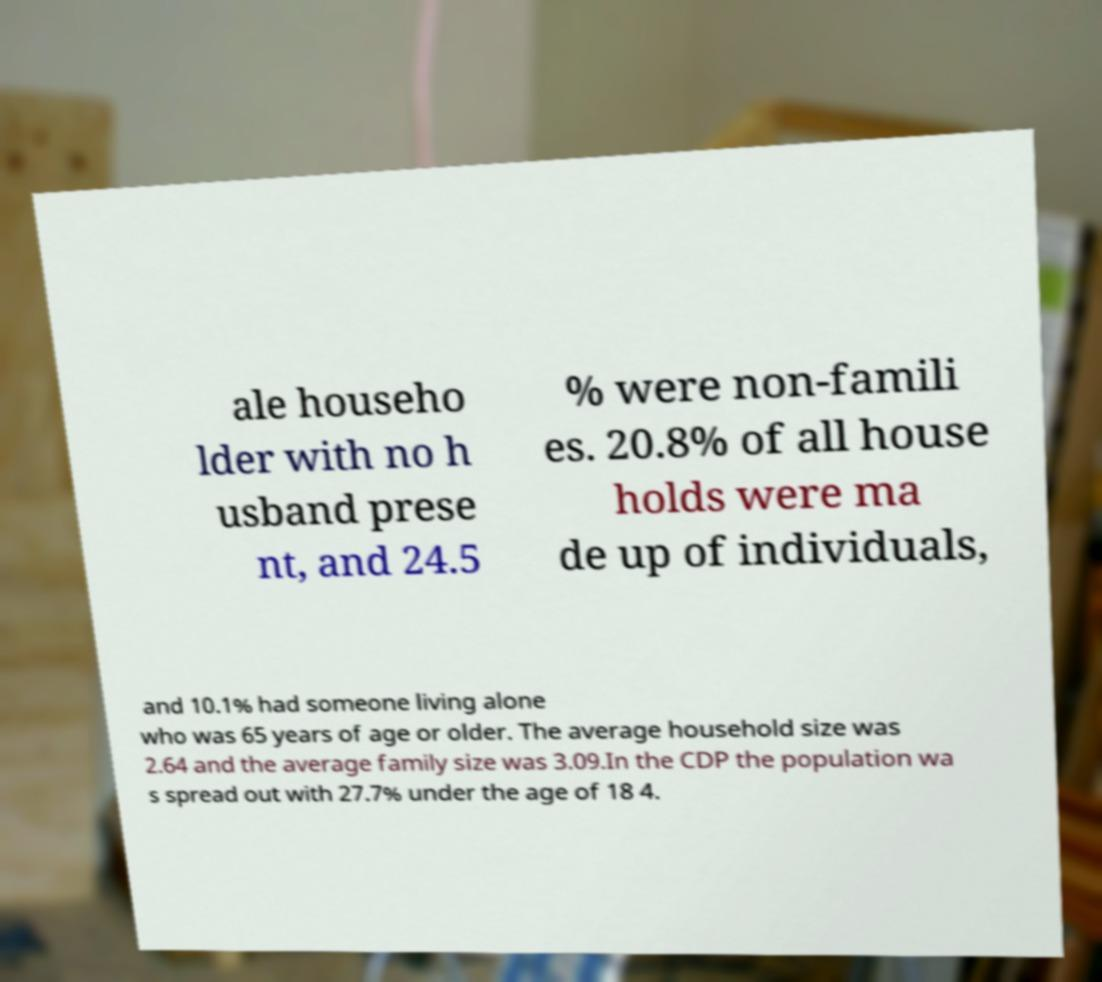Please read and relay the text visible in this image. What does it say? ale househo lder with no h usband prese nt, and 24.5 % were non-famili es. 20.8% of all house holds were ma de up of individuals, and 10.1% had someone living alone who was 65 years of age or older. The average household size was 2.64 and the average family size was 3.09.In the CDP the population wa s spread out with 27.7% under the age of 18 4. 